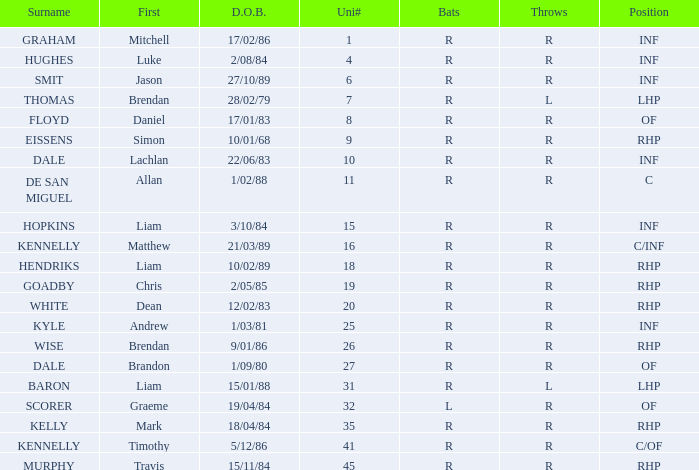Which athlete's surname is baron? R. 